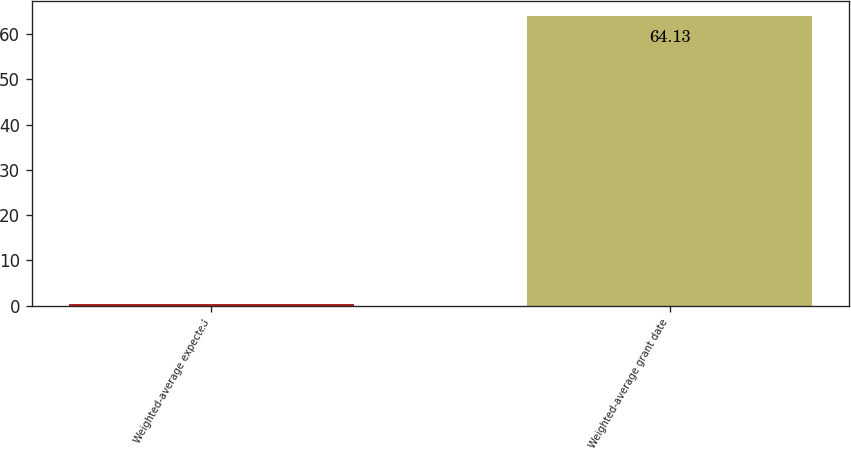Convert chart to OTSL. <chart><loc_0><loc_0><loc_500><loc_500><bar_chart><fcel>Weighted-average expected<fcel>Weighted-average grant date<nl><fcel>0.3<fcel>64.13<nl></chart> 